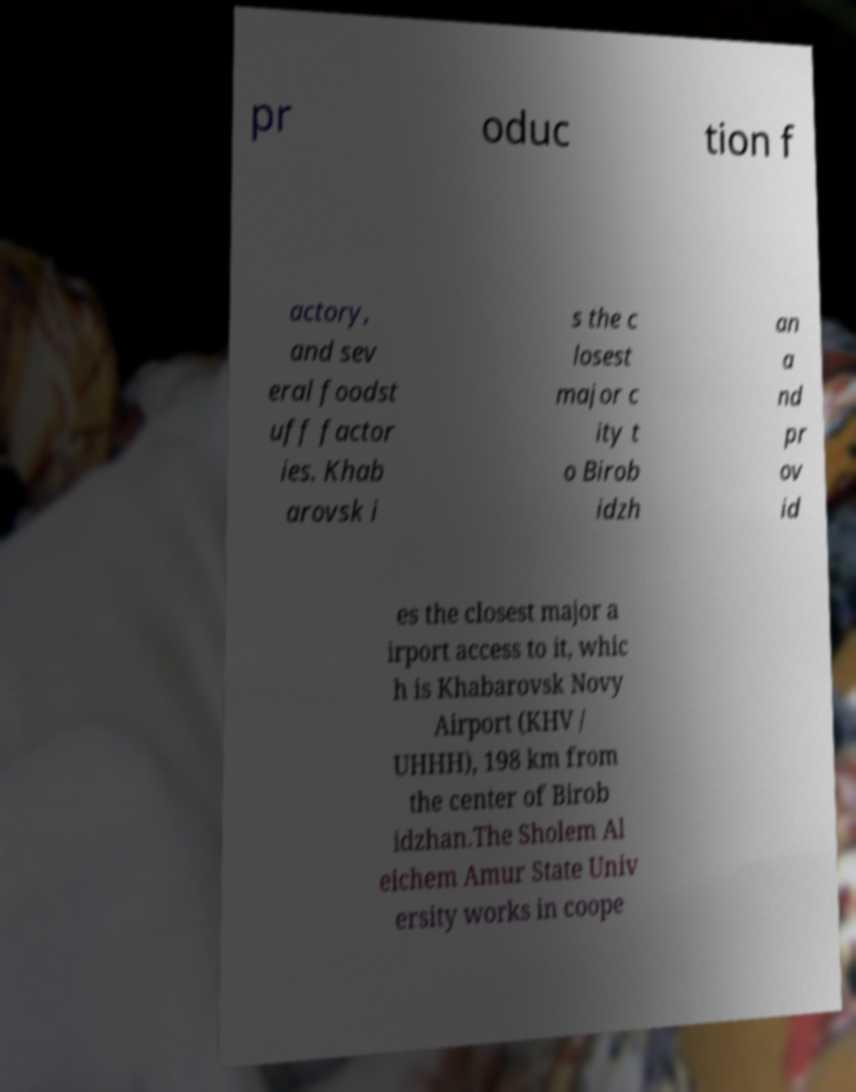Can you accurately transcribe the text from the provided image for me? pr oduc tion f actory, and sev eral foodst uff factor ies. Khab arovsk i s the c losest major c ity t o Birob idzh an a nd pr ov id es the closest major a irport access to it, whic h is Khabarovsk Novy Airport (KHV / UHHH), 198 km from the center of Birob idzhan.The Sholem Al eichem Amur State Univ ersity works in coope 